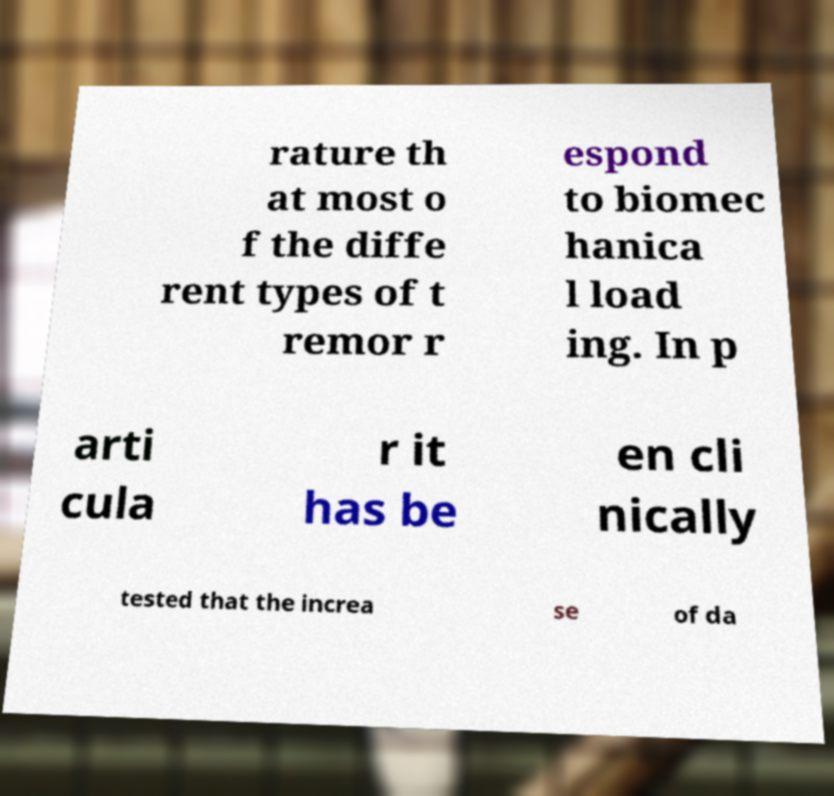What messages or text are displayed in this image? I need them in a readable, typed format. rature th at most o f the diffe rent types of t remor r espond to biomec hanica l load ing. In p arti cula r it has be en cli nically tested that the increa se of da 